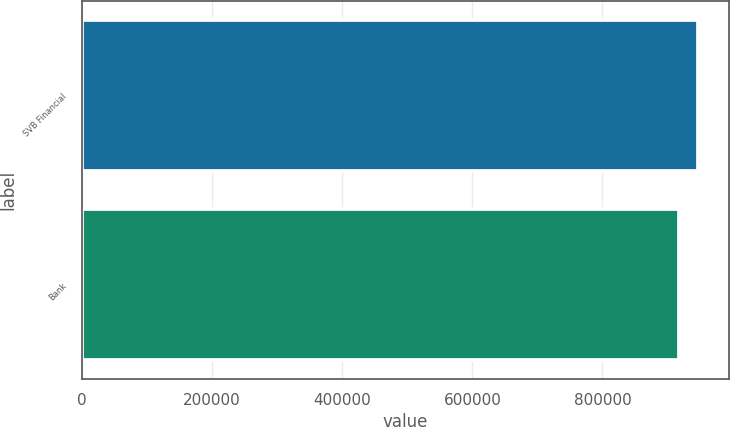Convert chart to OTSL. <chart><loc_0><loc_0><loc_500><loc_500><bar_chart><fcel>SVB Financial<fcel>Bank<nl><fcel>947032<fcel>917392<nl></chart> 